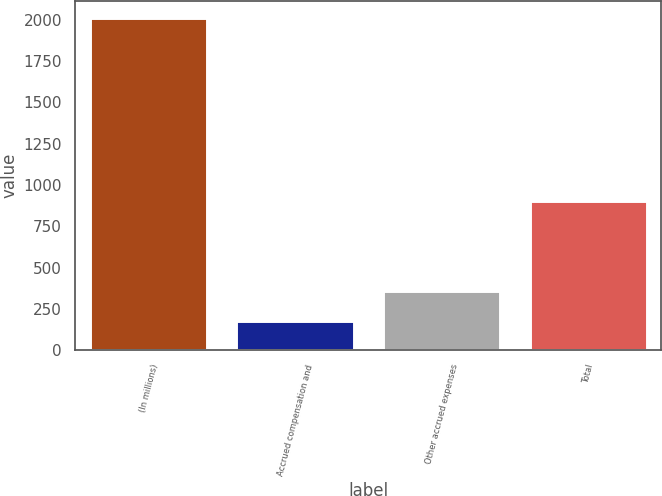<chart> <loc_0><loc_0><loc_500><loc_500><bar_chart><fcel>(In millions)<fcel>Accrued compensation and<fcel>Other accrued expenses<fcel>Total<nl><fcel>2014<fcel>176<fcel>359.8<fcel>905<nl></chart> 